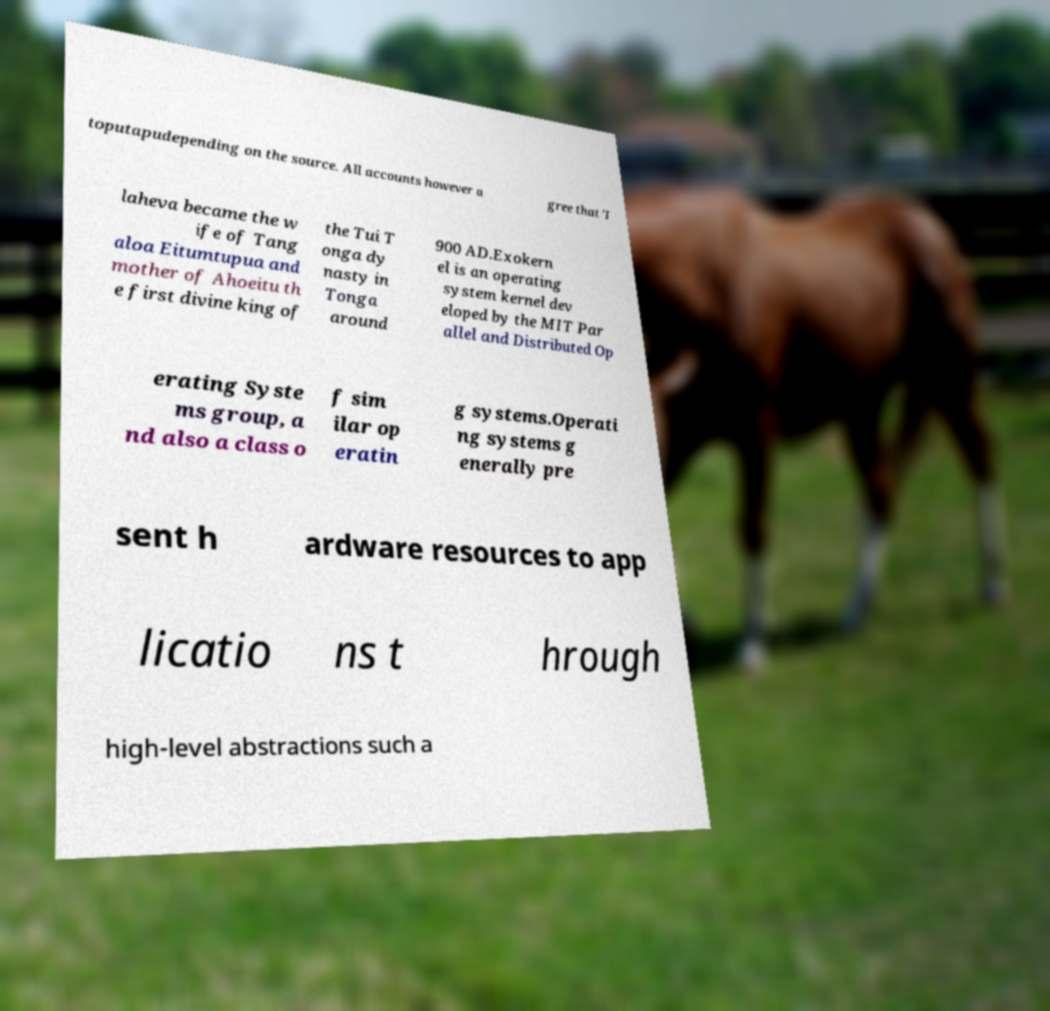Can you accurately transcribe the text from the provided image for me? toputapudepending on the source. All accounts however a gree that 'I laheva became the w ife of Tang aloa Eitumtupua and mother of Ahoeitu th e first divine king of the Tui T onga dy nasty in Tonga around 900 AD.Exokern el is an operating system kernel dev eloped by the MIT Par allel and Distributed Op erating Syste ms group, a nd also a class o f sim ilar op eratin g systems.Operati ng systems g enerally pre sent h ardware resources to app licatio ns t hrough high-level abstractions such a 